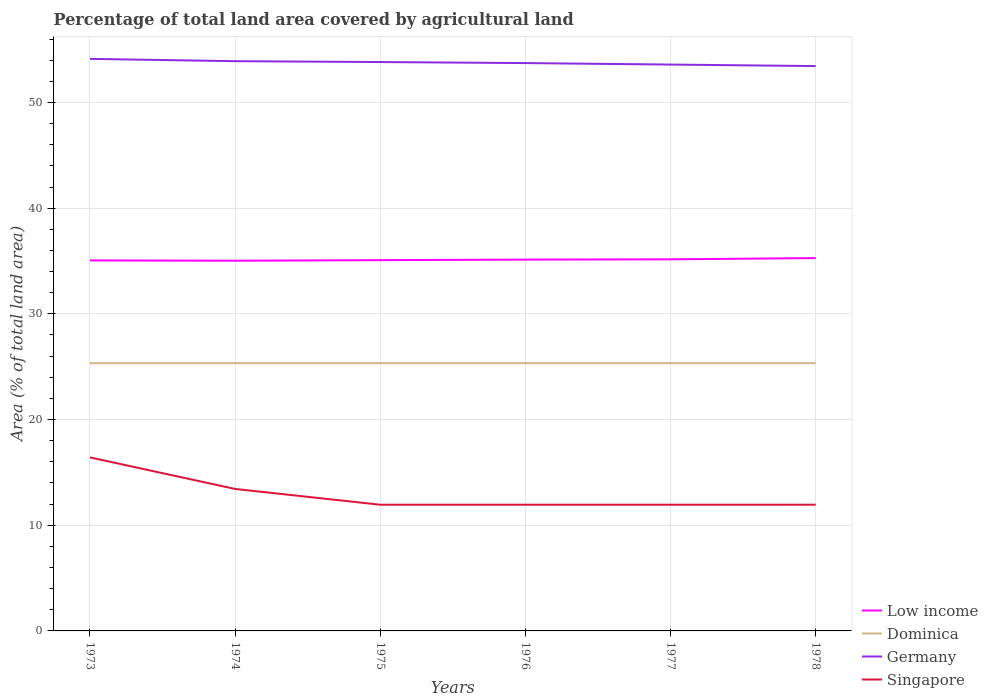How many different coloured lines are there?
Offer a very short reply. 4. Across all years, what is the maximum percentage of agricultural land in Singapore?
Keep it short and to the point. 11.94. In which year was the percentage of agricultural land in Low income maximum?
Provide a succinct answer. 1974. What is the total percentage of agricultural land in Germany in the graph?
Provide a succinct answer. 0.22. What is the difference between the highest and the second highest percentage of agricultural land in Germany?
Offer a very short reply. 0.68. How many lines are there?
Offer a terse response. 4. What is the difference between two consecutive major ticks on the Y-axis?
Provide a succinct answer. 10. How are the legend labels stacked?
Offer a terse response. Vertical. What is the title of the graph?
Provide a succinct answer. Percentage of total land area covered by agricultural land. Does "Equatorial Guinea" appear as one of the legend labels in the graph?
Make the answer very short. No. What is the label or title of the X-axis?
Keep it short and to the point. Years. What is the label or title of the Y-axis?
Ensure brevity in your answer.  Area (% of total land area). What is the Area (% of total land area) of Low income in 1973?
Keep it short and to the point. 35.06. What is the Area (% of total land area) in Dominica in 1973?
Offer a very short reply. 25.33. What is the Area (% of total land area) in Germany in 1973?
Give a very brief answer. 54.13. What is the Area (% of total land area) of Singapore in 1973?
Keep it short and to the point. 16.42. What is the Area (% of total land area) of Low income in 1974?
Your response must be concise. 35.03. What is the Area (% of total land area) in Dominica in 1974?
Your answer should be compact. 25.33. What is the Area (% of total land area) in Germany in 1974?
Your response must be concise. 53.91. What is the Area (% of total land area) in Singapore in 1974?
Offer a terse response. 13.43. What is the Area (% of total land area) of Low income in 1975?
Keep it short and to the point. 35.08. What is the Area (% of total land area) of Dominica in 1975?
Offer a terse response. 25.33. What is the Area (% of total land area) in Germany in 1975?
Ensure brevity in your answer.  53.83. What is the Area (% of total land area) of Singapore in 1975?
Make the answer very short. 11.94. What is the Area (% of total land area) in Low income in 1976?
Give a very brief answer. 35.13. What is the Area (% of total land area) in Dominica in 1976?
Ensure brevity in your answer.  25.33. What is the Area (% of total land area) of Germany in 1976?
Provide a short and direct response. 53.73. What is the Area (% of total land area) of Singapore in 1976?
Your answer should be compact. 11.94. What is the Area (% of total land area) in Low income in 1977?
Give a very brief answer. 35.16. What is the Area (% of total land area) in Dominica in 1977?
Give a very brief answer. 25.33. What is the Area (% of total land area) in Germany in 1977?
Your answer should be very brief. 53.59. What is the Area (% of total land area) in Singapore in 1977?
Make the answer very short. 11.94. What is the Area (% of total land area) of Low income in 1978?
Provide a succinct answer. 35.28. What is the Area (% of total land area) in Dominica in 1978?
Ensure brevity in your answer.  25.33. What is the Area (% of total land area) in Germany in 1978?
Keep it short and to the point. 53.44. What is the Area (% of total land area) of Singapore in 1978?
Offer a very short reply. 11.94. Across all years, what is the maximum Area (% of total land area) in Low income?
Offer a very short reply. 35.28. Across all years, what is the maximum Area (% of total land area) in Dominica?
Your response must be concise. 25.33. Across all years, what is the maximum Area (% of total land area) in Germany?
Offer a terse response. 54.13. Across all years, what is the maximum Area (% of total land area) of Singapore?
Your response must be concise. 16.42. Across all years, what is the minimum Area (% of total land area) in Low income?
Give a very brief answer. 35.03. Across all years, what is the minimum Area (% of total land area) of Dominica?
Make the answer very short. 25.33. Across all years, what is the minimum Area (% of total land area) in Germany?
Your answer should be very brief. 53.44. Across all years, what is the minimum Area (% of total land area) in Singapore?
Offer a terse response. 11.94. What is the total Area (% of total land area) in Low income in the graph?
Provide a short and direct response. 210.73. What is the total Area (% of total land area) in Dominica in the graph?
Ensure brevity in your answer.  152. What is the total Area (% of total land area) in Germany in the graph?
Offer a very short reply. 322.62. What is the total Area (% of total land area) of Singapore in the graph?
Give a very brief answer. 77.61. What is the difference between the Area (% of total land area) in Low income in 1973 and that in 1974?
Provide a succinct answer. 0.03. What is the difference between the Area (% of total land area) of Dominica in 1973 and that in 1974?
Offer a terse response. 0. What is the difference between the Area (% of total land area) of Germany in 1973 and that in 1974?
Keep it short and to the point. 0.22. What is the difference between the Area (% of total land area) of Singapore in 1973 and that in 1974?
Your response must be concise. 2.99. What is the difference between the Area (% of total land area) of Low income in 1973 and that in 1975?
Ensure brevity in your answer.  -0.02. What is the difference between the Area (% of total land area) in Dominica in 1973 and that in 1975?
Ensure brevity in your answer.  0. What is the difference between the Area (% of total land area) of Germany in 1973 and that in 1975?
Ensure brevity in your answer.  0.3. What is the difference between the Area (% of total land area) of Singapore in 1973 and that in 1975?
Make the answer very short. 4.48. What is the difference between the Area (% of total land area) of Low income in 1973 and that in 1976?
Offer a very short reply. -0.07. What is the difference between the Area (% of total land area) of Dominica in 1973 and that in 1976?
Provide a succinct answer. 0. What is the difference between the Area (% of total land area) of Germany in 1973 and that in 1976?
Your answer should be compact. 0.4. What is the difference between the Area (% of total land area) of Singapore in 1973 and that in 1976?
Give a very brief answer. 4.48. What is the difference between the Area (% of total land area) in Low income in 1973 and that in 1977?
Offer a very short reply. -0.1. What is the difference between the Area (% of total land area) of Germany in 1973 and that in 1977?
Keep it short and to the point. 0.54. What is the difference between the Area (% of total land area) of Singapore in 1973 and that in 1977?
Provide a short and direct response. 4.48. What is the difference between the Area (% of total land area) of Low income in 1973 and that in 1978?
Offer a terse response. -0.22. What is the difference between the Area (% of total land area) of Dominica in 1973 and that in 1978?
Provide a succinct answer. 0. What is the difference between the Area (% of total land area) in Germany in 1973 and that in 1978?
Offer a very short reply. 0.68. What is the difference between the Area (% of total land area) in Singapore in 1973 and that in 1978?
Offer a terse response. 4.48. What is the difference between the Area (% of total land area) in Low income in 1974 and that in 1975?
Provide a short and direct response. -0.05. What is the difference between the Area (% of total land area) in Germany in 1974 and that in 1975?
Provide a succinct answer. 0.08. What is the difference between the Area (% of total land area) of Singapore in 1974 and that in 1975?
Make the answer very short. 1.49. What is the difference between the Area (% of total land area) in Low income in 1974 and that in 1976?
Give a very brief answer. -0.11. What is the difference between the Area (% of total land area) in Germany in 1974 and that in 1976?
Give a very brief answer. 0.18. What is the difference between the Area (% of total land area) of Singapore in 1974 and that in 1976?
Your answer should be compact. 1.49. What is the difference between the Area (% of total land area) in Low income in 1974 and that in 1977?
Your answer should be compact. -0.13. What is the difference between the Area (% of total land area) in Dominica in 1974 and that in 1977?
Offer a very short reply. 0. What is the difference between the Area (% of total land area) in Germany in 1974 and that in 1977?
Your answer should be compact. 0.32. What is the difference between the Area (% of total land area) of Singapore in 1974 and that in 1977?
Offer a terse response. 1.49. What is the difference between the Area (% of total land area) of Low income in 1974 and that in 1978?
Keep it short and to the point. -0.25. What is the difference between the Area (% of total land area) of Germany in 1974 and that in 1978?
Offer a very short reply. 0.46. What is the difference between the Area (% of total land area) in Singapore in 1974 and that in 1978?
Ensure brevity in your answer.  1.49. What is the difference between the Area (% of total land area) in Low income in 1975 and that in 1976?
Your answer should be compact. -0.05. What is the difference between the Area (% of total land area) in Germany in 1975 and that in 1976?
Your answer should be very brief. 0.1. What is the difference between the Area (% of total land area) of Singapore in 1975 and that in 1976?
Your answer should be very brief. 0. What is the difference between the Area (% of total land area) of Low income in 1975 and that in 1977?
Make the answer very short. -0.08. What is the difference between the Area (% of total land area) of Dominica in 1975 and that in 1977?
Your answer should be very brief. 0. What is the difference between the Area (% of total land area) in Germany in 1975 and that in 1977?
Offer a terse response. 0.24. What is the difference between the Area (% of total land area) of Singapore in 1975 and that in 1977?
Your answer should be compact. 0. What is the difference between the Area (% of total land area) of Low income in 1975 and that in 1978?
Offer a terse response. -0.19. What is the difference between the Area (% of total land area) of Germany in 1975 and that in 1978?
Ensure brevity in your answer.  0.38. What is the difference between the Area (% of total land area) of Low income in 1976 and that in 1977?
Provide a short and direct response. -0.03. What is the difference between the Area (% of total land area) of Germany in 1976 and that in 1977?
Your answer should be compact. 0.14. What is the difference between the Area (% of total land area) in Singapore in 1976 and that in 1977?
Make the answer very short. 0. What is the difference between the Area (% of total land area) in Low income in 1976 and that in 1978?
Your answer should be compact. -0.14. What is the difference between the Area (% of total land area) in Dominica in 1976 and that in 1978?
Keep it short and to the point. 0. What is the difference between the Area (% of total land area) in Germany in 1976 and that in 1978?
Offer a terse response. 0.28. What is the difference between the Area (% of total land area) of Singapore in 1976 and that in 1978?
Your response must be concise. 0. What is the difference between the Area (% of total land area) in Low income in 1977 and that in 1978?
Offer a very short reply. -0.12. What is the difference between the Area (% of total land area) in Germany in 1977 and that in 1978?
Provide a short and direct response. 0.14. What is the difference between the Area (% of total land area) in Low income in 1973 and the Area (% of total land area) in Dominica in 1974?
Make the answer very short. 9.72. What is the difference between the Area (% of total land area) of Low income in 1973 and the Area (% of total land area) of Germany in 1974?
Your answer should be compact. -18.85. What is the difference between the Area (% of total land area) in Low income in 1973 and the Area (% of total land area) in Singapore in 1974?
Provide a succinct answer. 21.62. What is the difference between the Area (% of total land area) in Dominica in 1973 and the Area (% of total land area) in Germany in 1974?
Provide a short and direct response. -28.57. What is the difference between the Area (% of total land area) in Dominica in 1973 and the Area (% of total land area) in Singapore in 1974?
Your answer should be very brief. 11.9. What is the difference between the Area (% of total land area) in Germany in 1973 and the Area (% of total land area) in Singapore in 1974?
Your answer should be compact. 40.69. What is the difference between the Area (% of total land area) of Low income in 1973 and the Area (% of total land area) of Dominica in 1975?
Your response must be concise. 9.72. What is the difference between the Area (% of total land area) of Low income in 1973 and the Area (% of total land area) of Germany in 1975?
Your answer should be compact. -18.77. What is the difference between the Area (% of total land area) in Low income in 1973 and the Area (% of total land area) in Singapore in 1975?
Provide a short and direct response. 23.12. What is the difference between the Area (% of total land area) of Dominica in 1973 and the Area (% of total land area) of Germany in 1975?
Provide a short and direct response. -28.49. What is the difference between the Area (% of total land area) of Dominica in 1973 and the Area (% of total land area) of Singapore in 1975?
Provide a succinct answer. 13.39. What is the difference between the Area (% of total land area) in Germany in 1973 and the Area (% of total land area) in Singapore in 1975?
Your response must be concise. 42.19. What is the difference between the Area (% of total land area) in Low income in 1973 and the Area (% of total land area) in Dominica in 1976?
Your answer should be very brief. 9.72. What is the difference between the Area (% of total land area) in Low income in 1973 and the Area (% of total land area) in Germany in 1976?
Keep it short and to the point. -18.67. What is the difference between the Area (% of total land area) in Low income in 1973 and the Area (% of total land area) in Singapore in 1976?
Your response must be concise. 23.12. What is the difference between the Area (% of total land area) of Dominica in 1973 and the Area (% of total land area) of Germany in 1976?
Give a very brief answer. -28.39. What is the difference between the Area (% of total land area) in Dominica in 1973 and the Area (% of total land area) in Singapore in 1976?
Offer a terse response. 13.39. What is the difference between the Area (% of total land area) of Germany in 1973 and the Area (% of total land area) of Singapore in 1976?
Your answer should be compact. 42.19. What is the difference between the Area (% of total land area) in Low income in 1973 and the Area (% of total land area) in Dominica in 1977?
Make the answer very short. 9.72. What is the difference between the Area (% of total land area) of Low income in 1973 and the Area (% of total land area) of Germany in 1977?
Make the answer very short. -18.53. What is the difference between the Area (% of total land area) of Low income in 1973 and the Area (% of total land area) of Singapore in 1977?
Ensure brevity in your answer.  23.12. What is the difference between the Area (% of total land area) of Dominica in 1973 and the Area (% of total land area) of Germany in 1977?
Ensure brevity in your answer.  -28.25. What is the difference between the Area (% of total land area) in Dominica in 1973 and the Area (% of total land area) in Singapore in 1977?
Offer a very short reply. 13.39. What is the difference between the Area (% of total land area) of Germany in 1973 and the Area (% of total land area) of Singapore in 1977?
Your answer should be compact. 42.19. What is the difference between the Area (% of total land area) of Low income in 1973 and the Area (% of total land area) of Dominica in 1978?
Ensure brevity in your answer.  9.72. What is the difference between the Area (% of total land area) of Low income in 1973 and the Area (% of total land area) of Germany in 1978?
Your answer should be very brief. -18.39. What is the difference between the Area (% of total land area) in Low income in 1973 and the Area (% of total land area) in Singapore in 1978?
Offer a terse response. 23.12. What is the difference between the Area (% of total land area) of Dominica in 1973 and the Area (% of total land area) of Germany in 1978?
Give a very brief answer. -28.11. What is the difference between the Area (% of total land area) of Dominica in 1973 and the Area (% of total land area) of Singapore in 1978?
Your response must be concise. 13.39. What is the difference between the Area (% of total land area) of Germany in 1973 and the Area (% of total land area) of Singapore in 1978?
Give a very brief answer. 42.19. What is the difference between the Area (% of total land area) of Low income in 1974 and the Area (% of total land area) of Dominica in 1975?
Make the answer very short. 9.69. What is the difference between the Area (% of total land area) of Low income in 1974 and the Area (% of total land area) of Germany in 1975?
Offer a very short reply. -18.8. What is the difference between the Area (% of total land area) of Low income in 1974 and the Area (% of total land area) of Singapore in 1975?
Keep it short and to the point. 23.09. What is the difference between the Area (% of total land area) in Dominica in 1974 and the Area (% of total land area) in Germany in 1975?
Make the answer very short. -28.49. What is the difference between the Area (% of total land area) of Dominica in 1974 and the Area (% of total land area) of Singapore in 1975?
Keep it short and to the point. 13.39. What is the difference between the Area (% of total land area) in Germany in 1974 and the Area (% of total land area) in Singapore in 1975?
Keep it short and to the point. 41.97. What is the difference between the Area (% of total land area) of Low income in 1974 and the Area (% of total land area) of Dominica in 1976?
Offer a very short reply. 9.69. What is the difference between the Area (% of total land area) in Low income in 1974 and the Area (% of total land area) in Germany in 1976?
Offer a very short reply. -18.7. What is the difference between the Area (% of total land area) in Low income in 1974 and the Area (% of total land area) in Singapore in 1976?
Provide a short and direct response. 23.09. What is the difference between the Area (% of total land area) in Dominica in 1974 and the Area (% of total land area) in Germany in 1976?
Offer a very short reply. -28.39. What is the difference between the Area (% of total land area) of Dominica in 1974 and the Area (% of total land area) of Singapore in 1976?
Your answer should be very brief. 13.39. What is the difference between the Area (% of total land area) of Germany in 1974 and the Area (% of total land area) of Singapore in 1976?
Ensure brevity in your answer.  41.97. What is the difference between the Area (% of total land area) of Low income in 1974 and the Area (% of total land area) of Dominica in 1977?
Offer a very short reply. 9.69. What is the difference between the Area (% of total land area) in Low income in 1974 and the Area (% of total land area) in Germany in 1977?
Keep it short and to the point. -18.56. What is the difference between the Area (% of total land area) in Low income in 1974 and the Area (% of total land area) in Singapore in 1977?
Keep it short and to the point. 23.09. What is the difference between the Area (% of total land area) in Dominica in 1974 and the Area (% of total land area) in Germany in 1977?
Make the answer very short. -28.25. What is the difference between the Area (% of total land area) in Dominica in 1974 and the Area (% of total land area) in Singapore in 1977?
Ensure brevity in your answer.  13.39. What is the difference between the Area (% of total land area) in Germany in 1974 and the Area (% of total land area) in Singapore in 1977?
Keep it short and to the point. 41.97. What is the difference between the Area (% of total land area) in Low income in 1974 and the Area (% of total land area) in Dominica in 1978?
Keep it short and to the point. 9.69. What is the difference between the Area (% of total land area) in Low income in 1974 and the Area (% of total land area) in Germany in 1978?
Provide a short and direct response. -18.42. What is the difference between the Area (% of total land area) in Low income in 1974 and the Area (% of total land area) in Singapore in 1978?
Your answer should be very brief. 23.09. What is the difference between the Area (% of total land area) of Dominica in 1974 and the Area (% of total land area) of Germany in 1978?
Give a very brief answer. -28.11. What is the difference between the Area (% of total land area) in Dominica in 1974 and the Area (% of total land area) in Singapore in 1978?
Provide a short and direct response. 13.39. What is the difference between the Area (% of total land area) of Germany in 1974 and the Area (% of total land area) of Singapore in 1978?
Offer a very short reply. 41.97. What is the difference between the Area (% of total land area) in Low income in 1975 and the Area (% of total land area) in Dominica in 1976?
Offer a terse response. 9.75. What is the difference between the Area (% of total land area) in Low income in 1975 and the Area (% of total land area) in Germany in 1976?
Make the answer very short. -18.65. What is the difference between the Area (% of total land area) in Low income in 1975 and the Area (% of total land area) in Singapore in 1976?
Make the answer very short. 23.14. What is the difference between the Area (% of total land area) in Dominica in 1975 and the Area (% of total land area) in Germany in 1976?
Your answer should be compact. -28.39. What is the difference between the Area (% of total land area) in Dominica in 1975 and the Area (% of total land area) in Singapore in 1976?
Offer a terse response. 13.39. What is the difference between the Area (% of total land area) of Germany in 1975 and the Area (% of total land area) of Singapore in 1976?
Provide a short and direct response. 41.88. What is the difference between the Area (% of total land area) in Low income in 1975 and the Area (% of total land area) in Dominica in 1977?
Offer a terse response. 9.75. What is the difference between the Area (% of total land area) in Low income in 1975 and the Area (% of total land area) in Germany in 1977?
Keep it short and to the point. -18.51. What is the difference between the Area (% of total land area) of Low income in 1975 and the Area (% of total land area) of Singapore in 1977?
Your answer should be very brief. 23.14. What is the difference between the Area (% of total land area) in Dominica in 1975 and the Area (% of total land area) in Germany in 1977?
Provide a succinct answer. -28.25. What is the difference between the Area (% of total land area) in Dominica in 1975 and the Area (% of total land area) in Singapore in 1977?
Provide a short and direct response. 13.39. What is the difference between the Area (% of total land area) of Germany in 1975 and the Area (% of total land area) of Singapore in 1977?
Your answer should be compact. 41.88. What is the difference between the Area (% of total land area) in Low income in 1975 and the Area (% of total land area) in Dominica in 1978?
Keep it short and to the point. 9.75. What is the difference between the Area (% of total land area) in Low income in 1975 and the Area (% of total land area) in Germany in 1978?
Give a very brief answer. -18.36. What is the difference between the Area (% of total land area) in Low income in 1975 and the Area (% of total land area) in Singapore in 1978?
Offer a terse response. 23.14. What is the difference between the Area (% of total land area) of Dominica in 1975 and the Area (% of total land area) of Germany in 1978?
Your answer should be compact. -28.11. What is the difference between the Area (% of total land area) in Dominica in 1975 and the Area (% of total land area) in Singapore in 1978?
Keep it short and to the point. 13.39. What is the difference between the Area (% of total land area) in Germany in 1975 and the Area (% of total land area) in Singapore in 1978?
Provide a succinct answer. 41.88. What is the difference between the Area (% of total land area) in Low income in 1976 and the Area (% of total land area) in Dominica in 1977?
Provide a short and direct response. 9.8. What is the difference between the Area (% of total land area) in Low income in 1976 and the Area (% of total land area) in Germany in 1977?
Make the answer very short. -18.46. What is the difference between the Area (% of total land area) of Low income in 1976 and the Area (% of total land area) of Singapore in 1977?
Offer a terse response. 23.19. What is the difference between the Area (% of total land area) of Dominica in 1976 and the Area (% of total land area) of Germany in 1977?
Provide a short and direct response. -28.25. What is the difference between the Area (% of total land area) in Dominica in 1976 and the Area (% of total land area) in Singapore in 1977?
Give a very brief answer. 13.39. What is the difference between the Area (% of total land area) in Germany in 1976 and the Area (% of total land area) in Singapore in 1977?
Your answer should be very brief. 41.79. What is the difference between the Area (% of total land area) in Low income in 1976 and the Area (% of total land area) in Dominica in 1978?
Make the answer very short. 9.8. What is the difference between the Area (% of total land area) in Low income in 1976 and the Area (% of total land area) in Germany in 1978?
Your response must be concise. -18.31. What is the difference between the Area (% of total land area) in Low income in 1976 and the Area (% of total land area) in Singapore in 1978?
Offer a very short reply. 23.19. What is the difference between the Area (% of total land area) in Dominica in 1976 and the Area (% of total land area) in Germany in 1978?
Provide a succinct answer. -28.11. What is the difference between the Area (% of total land area) of Dominica in 1976 and the Area (% of total land area) of Singapore in 1978?
Give a very brief answer. 13.39. What is the difference between the Area (% of total land area) in Germany in 1976 and the Area (% of total land area) in Singapore in 1978?
Your answer should be compact. 41.79. What is the difference between the Area (% of total land area) of Low income in 1977 and the Area (% of total land area) of Dominica in 1978?
Keep it short and to the point. 9.83. What is the difference between the Area (% of total land area) of Low income in 1977 and the Area (% of total land area) of Germany in 1978?
Offer a terse response. -18.28. What is the difference between the Area (% of total land area) in Low income in 1977 and the Area (% of total land area) in Singapore in 1978?
Provide a short and direct response. 23.22. What is the difference between the Area (% of total land area) in Dominica in 1977 and the Area (% of total land area) in Germany in 1978?
Provide a short and direct response. -28.11. What is the difference between the Area (% of total land area) of Dominica in 1977 and the Area (% of total land area) of Singapore in 1978?
Provide a short and direct response. 13.39. What is the difference between the Area (% of total land area) of Germany in 1977 and the Area (% of total land area) of Singapore in 1978?
Ensure brevity in your answer.  41.65. What is the average Area (% of total land area) of Low income per year?
Ensure brevity in your answer.  35.12. What is the average Area (% of total land area) in Dominica per year?
Your answer should be very brief. 25.33. What is the average Area (% of total land area) of Germany per year?
Give a very brief answer. 53.77. What is the average Area (% of total land area) in Singapore per year?
Your response must be concise. 12.94. In the year 1973, what is the difference between the Area (% of total land area) in Low income and Area (% of total land area) in Dominica?
Give a very brief answer. 9.72. In the year 1973, what is the difference between the Area (% of total land area) in Low income and Area (% of total land area) in Germany?
Make the answer very short. -19.07. In the year 1973, what is the difference between the Area (% of total land area) of Low income and Area (% of total land area) of Singapore?
Offer a terse response. 18.64. In the year 1973, what is the difference between the Area (% of total land area) in Dominica and Area (% of total land area) in Germany?
Keep it short and to the point. -28.79. In the year 1973, what is the difference between the Area (% of total land area) of Dominica and Area (% of total land area) of Singapore?
Your answer should be compact. 8.92. In the year 1973, what is the difference between the Area (% of total land area) in Germany and Area (% of total land area) in Singapore?
Your response must be concise. 37.71. In the year 1974, what is the difference between the Area (% of total land area) of Low income and Area (% of total land area) of Dominica?
Keep it short and to the point. 9.69. In the year 1974, what is the difference between the Area (% of total land area) of Low income and Area (% of total land area) of Germany?
Give a very brief answer. -18.88. In the year 1974, what is the difference between the Area (% of total land area) in Low income and Area (% of total land area) in Singapore?
Your response must be concise. 21.59. In the year 1974, what is the difference between the Area (% of total land area) in Dominica and Area (% of total land area) in Germany?
Provide a succinct answer. -28.57. In the year 1974, what is the difference between the Area (% of total land area) in Dominica and Area (% of total land area) in Singapore?
Provide a short and direct response. 11.9. In the year 1974, what is the difference between the Area (% of total land area) in Germany and Area (% of total land area) in Singapore?
Your answer should be very brief. 40.48. In the year 1975, what is the difference between the Area (% of total land area) in Low income and Area (% of total land area) in Dominica?
Provide a succinct answer. 9.75. In the year 1975, what is the difference between the Area (% of total land area) of Low income and Area (% of total land area) of Germany?
Provide a succinct answer. -18.74. In the year 1975, what is the difference between the Area (% of total land area) in Low income and Area (% of total land area) in Singapore?
Provide a short and direct response. 23.14. In the year 1975, what is the difference between the Area (% of total land area) in Dominica and Area (% of total land area) in Germany?
Make the answer very short. -28.49. In the year 1975, what is the difference between the Area (% of total land area) of Dominica and Area (% of total land area) of Singapore?
Keep it short and to the point. 13.39. In the year 1975, what is the difference between the Area (% of total land area) of Germany and Area (% of total land area) of Singapore?
Make the answer very short. 41.88. In the year 1976, what is the difference between the Area (% of total land area) in Low income and Area (% of total land area) in Dominica?
Your answer should be compact. 9.8. In the year 1976, what is the difference between the Area (% of total land area) in Low income and Area (% of total land area) in Germany?
Your response must be concise. -18.6. In the year 1976, what is the difference between the Area (% of total land area) in Low income and Area (% of total land area) in Singapore?
Ensure brevity in your answer.  23.19. In the year 1976, what is the difference between the Area (% of total land area) in Dominica and Area (% of total land area) in Germany?
Keep it short and to the point. -28.39. In the year 1976, what is the difference between the Area (% of total land area) in Dominica and Area (% of total land area) in Singapore?
Keep it short and to the point. 13.39. In the year 1976, what is the difference between the Area (% of total land area) of Germany and Area (% of total land area) of Singapore?
Give a very brief answer. 41.79. In the year 1977, what is the difference between the Area (% of total land area) in Low income and Area (% of total land area) in Dominica?
Ensure brevity in your answer.  9.83. In the year 1977, what is the difference between the Area (% of total land area) of Low income and Area (% of total land area) of Germany?
Offer a very short reply. -18.43. In the year 1977, what is the difference between the Area (% of total land area) in Low income and Area (% of total land area) in Singapore?
Ensure brevity in your answer.  23.22. In the year 1977, what is the difference between the Area (% of total land area) in Dominica and Area (% of total land area) in Germany?
Provide a short and direct response. -28.25. In the year 1977, what is the difference between the Area (% of total land area) of Dominica and Area (% of total land area) of Singapore?
Make the answer very short. 13.39. In the year 1977, what is the difference between the Area (% of total land area) in Germany and Area (% of total land area) in Singapore?
Provide a short and direct response. 41.65. In the year 1978, what is the difference between the Area (% of total land area) of Low income and Area (% of total land area) of Dominica?
Give a very brief answer. 9.94. In the year 1978, what is the difference between the Area (% of total land area) of Low income and Area (% of total land area) of Germany?
Keep it short and to the point. -18.17. In the year 1978, what is the difference between the Area (% of total land area) of Low income and Area (% of total land area) of Singapore?
Provide a succinct answer. 23.34. In the year 1978, what is the difference between the Area (% of total land area) in Dominica and Area (% of total land area) in Germany?
Provide a succinct answer. -28.11. In the year 1978, what is the difference between the Area (% of total land area) in Dominica and Area (% of total land area) in Singapore?
Offer a terse response. 13.39. In the year 1978, what is the difference between the Area (% of total land area) in Germany and Area (% of total land area) in Singapore?
Your answer should be very brief. 41.5. What is the ratio of the Area (% of total land area) of Low income in 1973 to that in 1974?
Offer a terse response. 1. What is the ratio of the Area (% of total land area) in Dominica in 1973 to that in 1974?
Offer a terse response. 1. What is the ratio of the Area (% of total land area) in Germany in 1973 to that in 1974?
Give a very brief answer. 1. What is the ratio of the Area (% of total land area) in Singapore in 1973 to that in 1974?
Your answer should be very brief. 1.22. What is the ratio of the Area (% of total land area) in Dominica in 1973 to that in 1975?
Provide a succinct answer. 1. What is the ratio of the Area (% of total land area) of Germany in 1973 to that in 1975?
Provide a succinct answer. 1.01. What is the ratio of the Area (% of total land area) in Singapore in 1973 to that in 1975?
Your answer should be very brief. 1.38. What is the ratio of the Area (% of total land area) of Dominica in 1973 to that in 1976?
Your answer should be very brief. 1. What is the ratio of the Area (% of total land area) in Germany in 1973 to that in 1976?
Make the answer very short. 1.01. What is the ratio of the Area (% of total land area) of Singapore in 1973 to that in 1976?
Keep it short and to the point. 1.38. What is the ratio of the Area (% of total land area) in Dominica in 1973 to that in 1977?
Offer a very short reply. 1. What is the ratio of the Area (% of total land area) of Singapore in 1973 to that in 1977?
Keep it short and to the point. 1.38. What is the ratio of the Area (% of total land area) of Dominica in 1973 to that in 1978?
Make the answer very short. 1. What is the ratio of the Area (% of total land area) of Germany in 1973 to that in 1978?
Give a very brief answer. 1.01. What is the ratio of the Area (% of total land area) of Singapore in 1973 to that in 1978?
Make the answer very short. 1.38. What is the ratio of the Area (% of total land area) in Low income in 1974 to that in 1975?
Make the answer very short. 1. What is the ratio of the Area (% of total land area) in Singapore in 1974 to that in 1975?
Provide a short and direct response. 1.12. What is the ratio of the Area (% of total land area) in Dominica in 1974 to that in 1976?
Make the answer very short. 1. What is the ratio of the Area (% of total land area) in Germany in 1974 to that in 1976?
Make the answer very short. 1. What is the ratio of the Area (% of total land area) of Singapore in 1974 to that in 1976?
Offer a terse response. 1.12. What is the ratio of the Area (% of total land area) in Low income in 1974 to that in 1977?
Give a very brief answer. 1. What is the ratio of the Area (% of total land area) in Dominica in 1974 to that in 1977?
Make the answer very short. 1. What is the ratio of the Area (% of total land area) of Singapore in 1974 to that in 1977?
Offer a very short reply. 1.12. What is the ratio of the Area (% of total land area) of Dominica in 1974 to that in 1978?
Your answer should be very brief. 1. What is the ratio of the Area (% of total land area) in Germany in 1974 to that in 1978?
Your response must be concise. 1.01. What is the ratio of the Area (% of total land area) in Singapore in 1974 to that in 1978?
Offer a very short reply. 1.12. What is the ratio of the Area (% of total land area) in Low income in 1975 to that in 1976?
Provide a succinct answer. 1. What is the ratio of the Area (% of total land area) in Singapore in 1975 to that in 1976?
Your answer should be compact. 1. What is the ratio of the Area (% of total land area) in Low income in 1975 to that in 1977?
Offer a very short reply. 1. What is the ratio of the Area (% of total land area) in Dominica in 1975 to that in 1977?
Provide a succinct answer. 1. What is the ratio of the Area (% of total land area) in Low income in 1975 to that in 1978?
Offer a very short reply. 0.99. What is the ratio of the Area (% of total land area) in Germany in 1975 to that in 1978?
Your answer should be very brief. 1.01. What is the ratio of the Area (% of total land area) of Singapore in 1975 to that in 1978?
Your answer should be very brief. 1. What is the ratio of the Area (% of total land area) of Germany in 1976 to that in 1977?
Ensure brevity in your answer.  1. What is the ratio of the Area (% of total land area) in Low income in 1976 to that in 1978?
Provide a short and direct response. 1. What is the ratio of the Area (% of total land area) of Germany in 1976 to that in 1978?
Ensure brevity in your answer.  1.01. What is the ratio of the Area (% of total land area) in Singapore in 1976 to that in 1978?
Provide a succinct answer. 1. What is the ratio of the Area (% of total land area) of Low income in 1977 to that in 1978?
Make the answer very short. 1. What is the ratio of the Area (% of total land area) in Dominica in 1977 to that in 1978?
Your answer should be compact. 1. What is the ratio of the Area (% of total land area) of Germany in 1977 to that in 1978?
Your answer should be compact. 1. What is the ratio of the Area (% of total land area) of Singapore in 1977 to that in 1978?
Your response must be concise. 1. What is the difference between the highest and the second highest Area (% of total land area) of Low income?
Offer a very short reply. 0.12. What is the difference between the highest and the second highest Area (% of total land area) of Dominica?
Provide a succinct answer. 0. What is the difference between the highest and the second highest Area (% of total land area) in Germany?
Ensure brevity in your answer.  0.22. What is the difference between the highest and the second highest Area (% of total land area) of Singapore?
Offer a very short reply. 2.99. What is the difference between the highest and the lowest Area (% of total land area) of Low income?
Your answer should be compact. 0.25. What is the difference between the highest and the lowest Area (% of total land area) of Germany?
Your response must be concise. 0.68. What is the difference between the highest and the lowest Area (% of total land area) of Singapore?
Offer a terse response. 4.48. 